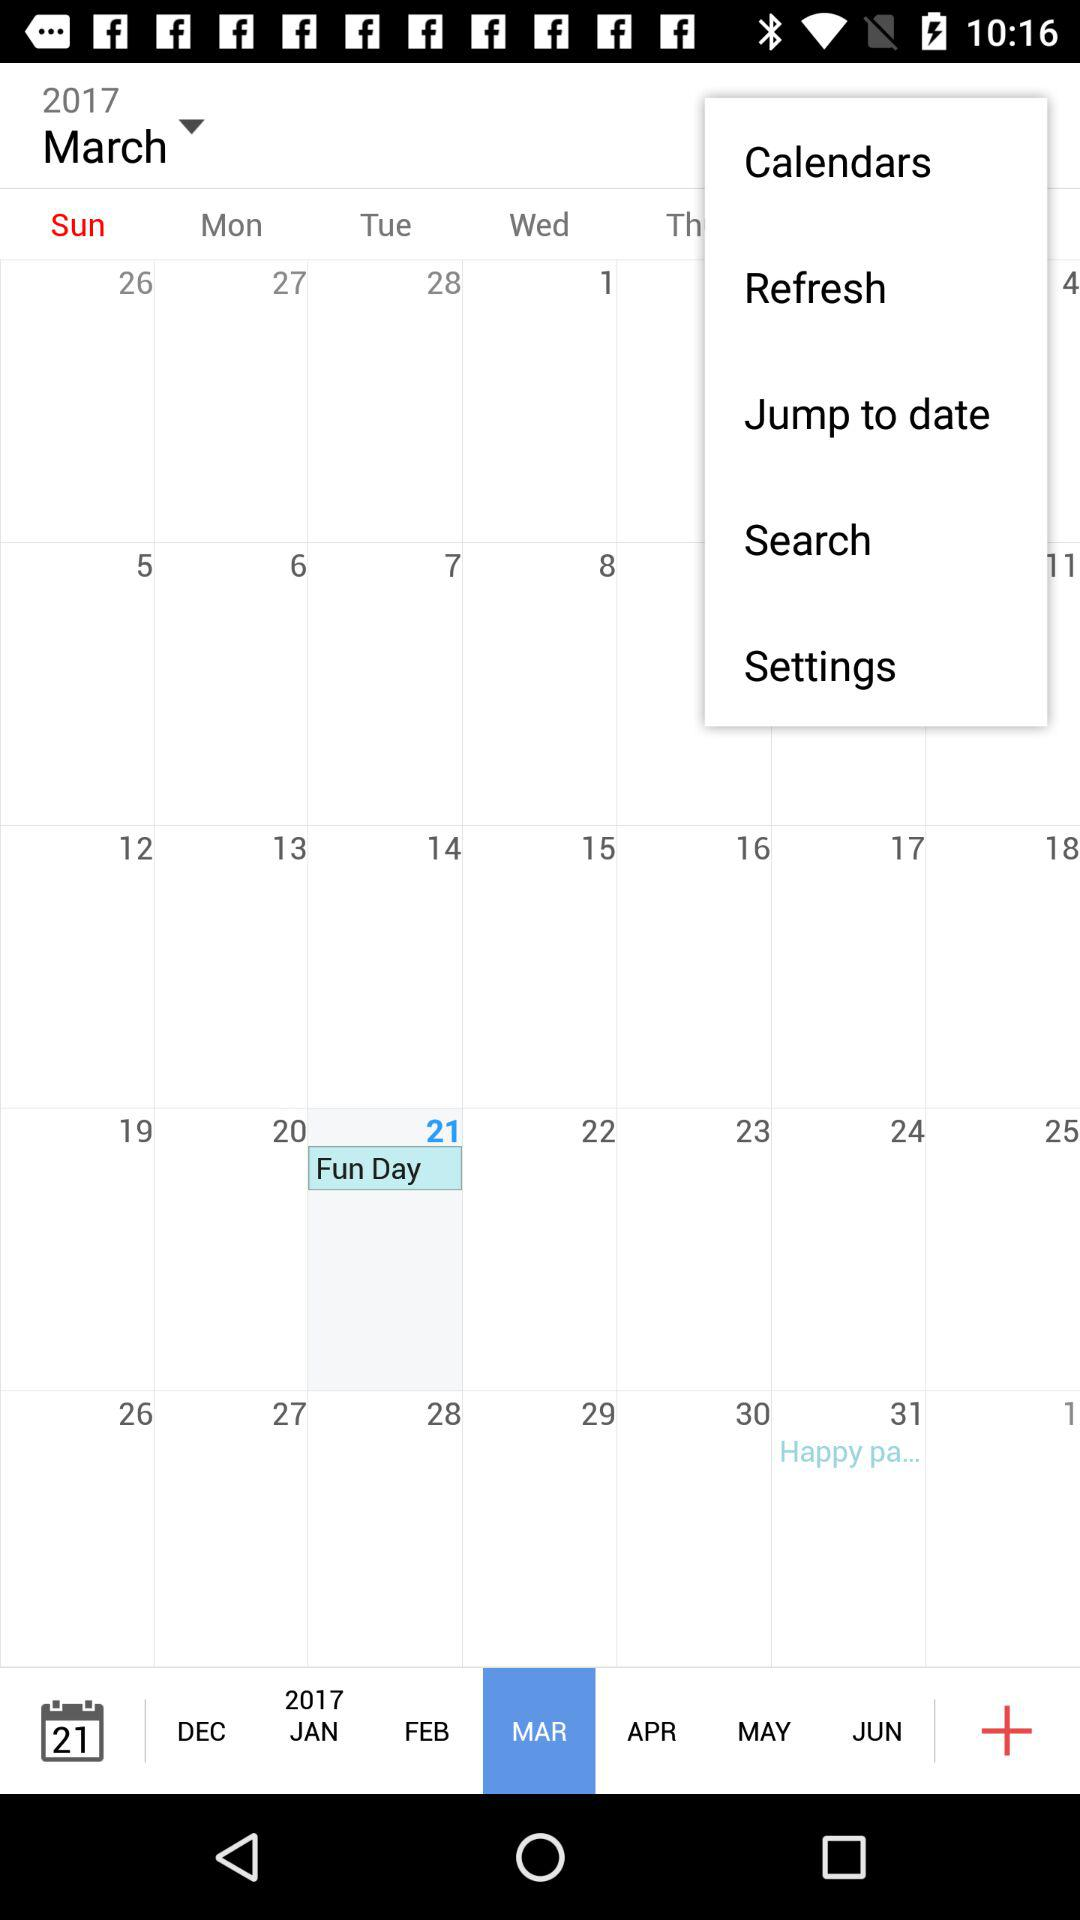What is the date on fun day? What is the date of Fun Day? The date of Fun Day is March 21, 2017. 